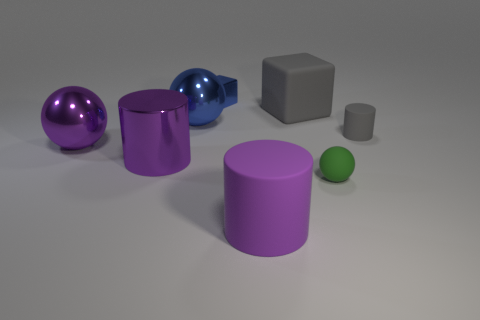The large cube is what color?
Make the answer very short. Gray. What is the shape of the gray rubber object that is in front of the cube that is to the right of the small metallic object?
Your answer should be compact. Cylinder. What number of spheres are small blue things or big purple rubber things?
Keep it short and to the point. 0. There is a ball that is the same color as the small metallic block; what is it made of?
Provide a succinct answer. Metal. Is the shape of the matte thing that is to the left of the gray matte block the same as the thing behind the gray matte cube?
Offer a terse response. No. There is a thing that is both behind the large blue metal ball and on the right side of the tiny blue metal thing; what color is it?
Offer a terse response. Gray. There is a big metal cylinder; does it have the same color as the big ball to the left of the big shiny cylinder?
Your answer should be very brief. Yes. What size is the cylinder that is both behind the small green matte sphere and to the right of the blue block?
Ensure brevity in your answer.  Small. How many other things are there of the same color as the small block?
Give a very brief answer. 1. What is the size of the ball on the left side of the cylinder that is on the left side of the cube to the left of the big purple matte object?
Offer a very short reply. Large. 